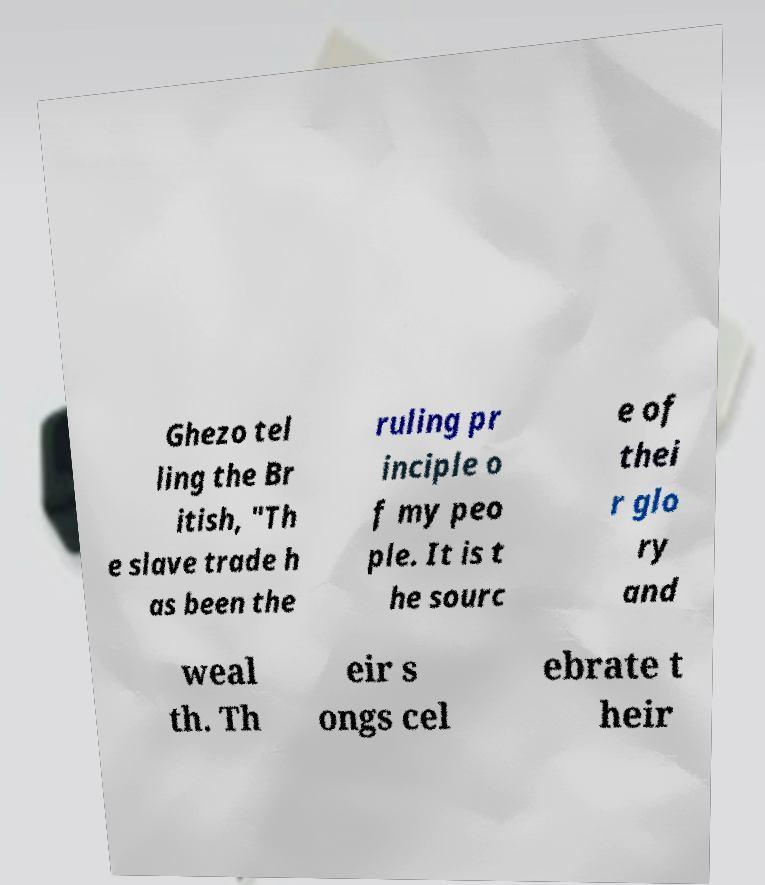Please read and relay the text visible in this image. What does it say? Ghezo tel ling the Br itish, "Th e slave trade h as been the ruling pr inciple o f my peo ple. It is t he sourc e of thei r glo ry and weal th. Th eir s ongs cel ebrate t heir 